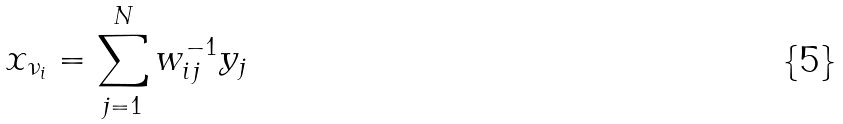Convert formula to latex. <formula><loc_0><loc_0><loc_500><loc_500>x _ { \nu _ { i } } = \sum _ { j = 1 } ^ { N } w _ { i j } ^ { - 1 } y _ { j } \\</formula> 